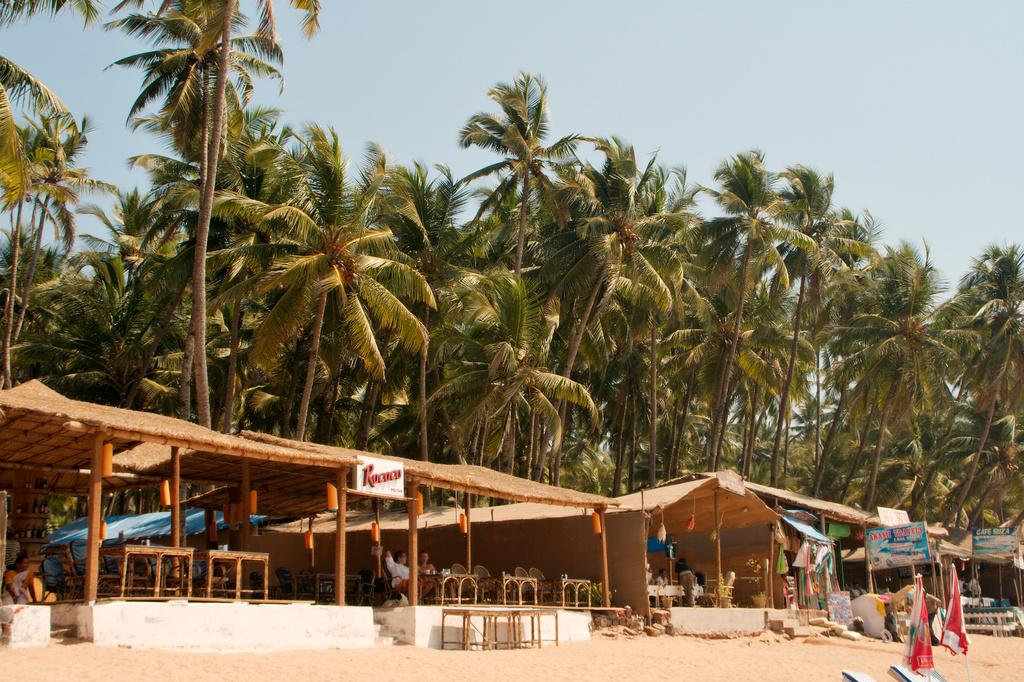What objects are present in the image that can provide shade or shelter? There are umbrellas and sheds in the image that can provide shade or shelter. What type of seating is available in the image? There are chairs in the image for seating. What type of surface is visible in the image? There is sand in the image, which suggests a beach or similar location. What type of furniture is present in the image? There are tables in the image, which can be used for placing items or eating. What type of material is present in the image? There are boards in the image, which could be used for construction or signage. Who is present in the image? There are people in the image, which suggests a social or recreational setting. What can be seen in the background of the image? Trees and the sky are visible in the background of the image, which provides context for the location and weather. What type of cord is being used to milk the cow in the image? There is no cow or cord present in the image; it features umbrellas, chairs, sand, tables, sheds, boards, people, trees, and the sky. What type of floor is visible in the image? There is no floor visible in the image; it features sand, which is a type of surface rather than a floor. 